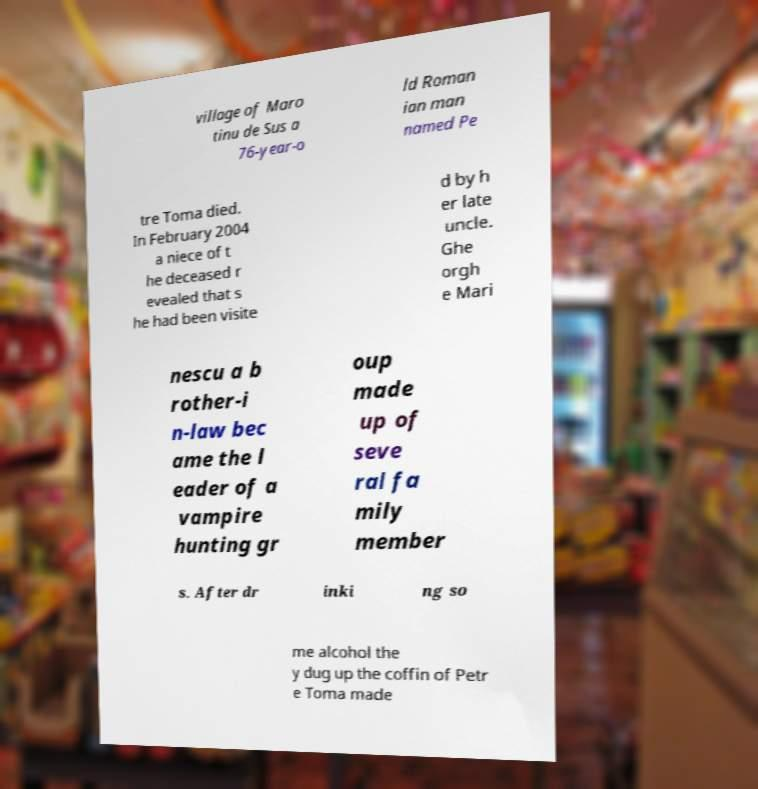For documentation purposes, I need the text within this image transcribed. Could you provide that? village of Maro tinu de Sus a 76-year-o ld Roman ian man named Pe tre Toma died. In February 2004 a niece of t he deceased r evealed that s he had been visite d by h er late uncle. Ghe orgh e Mari nescu a b rother-i n-law bec ame the l eader of a vampire hunting gr oup made up of seve ral fa mily member s. After dr inki ng so me alcohol the y dug up the coffin of Petr e Toma made 